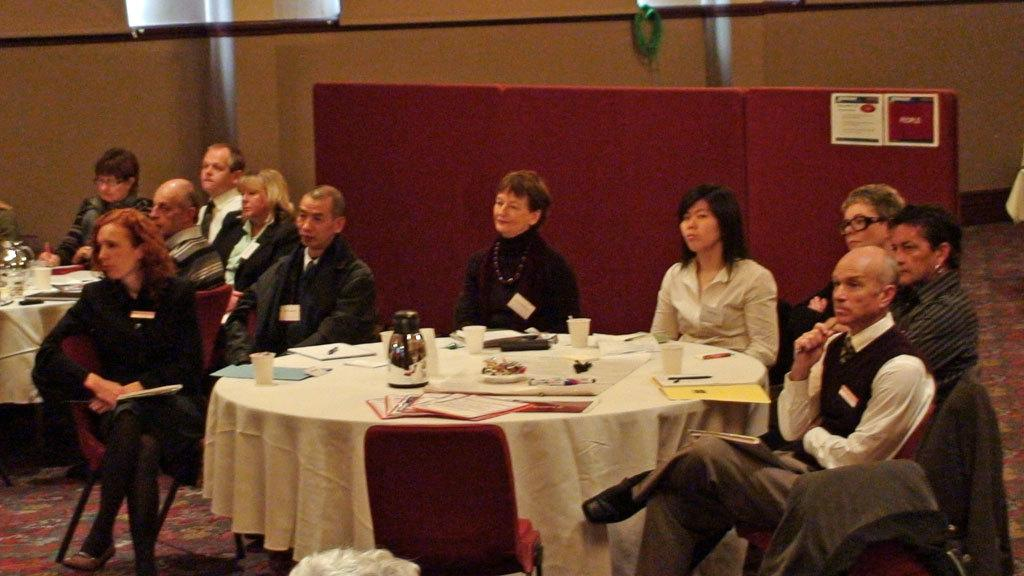What type of furniture is present in the image? There are tables and chairs in the image. What objects can be seen on the tables? There is a kettle, papers, books, cups, and mobile phones on the tables. What are the people in the image doing? People are sitting on chairs and sitting around tables. How many tables and chairs are visible in the image? The number of tables and chairs is not specified, but there are multiple tables and chairs present. How does the corn increase in size in the image? There is no corn present in the image, so it cannot increase in size. What type of destruction is depicted in the image? There is no destruction depicted in the image; it features tables, chairs, and people engaged in various activities. 